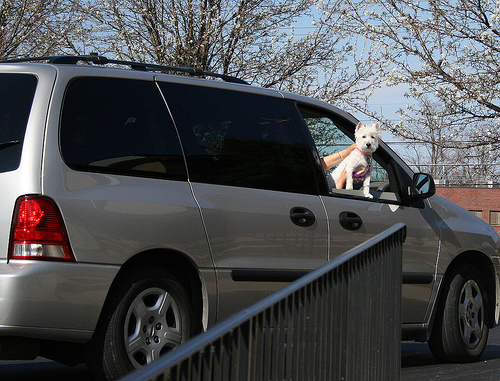<image>
Is there a sky behind the dog? Yes. From this viewpoint, the sky is positioned behind the dog, with the dog partially or fully occluding the sky. 